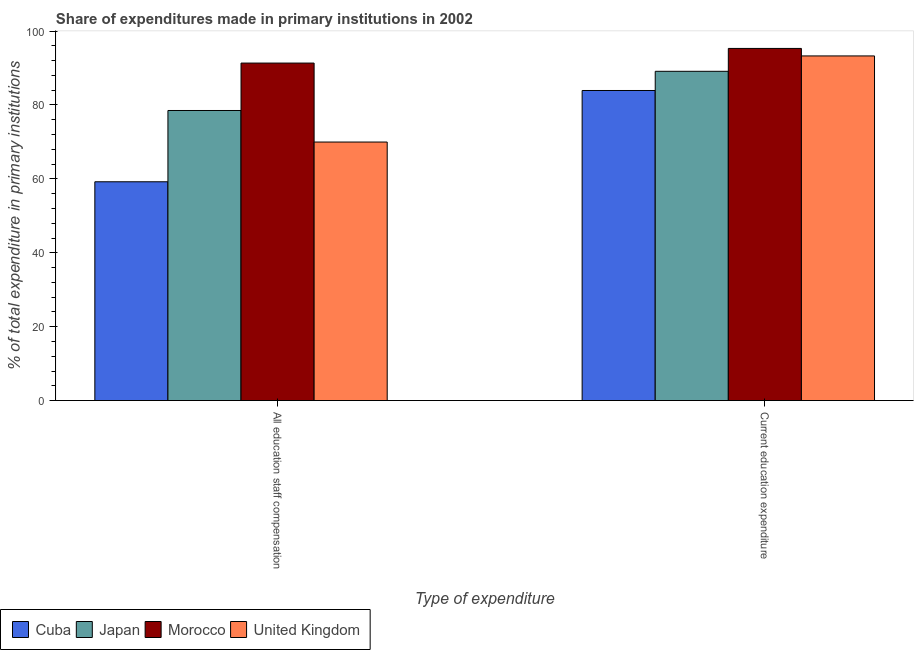How many different coloured bars are there?
Offer a terse response. 4. Are the number of bars on each tick of the X-axis equal?
Provide a short and direct response. Yes. How many bars are there on the 1st tick from the left?
Make the answer very short. 4. How many bars are there on the 1st tick from the right?
Offer a terse response. 4. What is the label of the 2nd group of bars from the left?
Make the answer very short. Current education expenditure. What is the expenditure in staff compensation in Morocco?
Ensure brevity in your answer.  91.35. Across all countries, what is the maximum expenditure in education?
Your answer should be compact. 95.31. Across all countries, what is the minimum expenditure in staff compensation?
Give a very brief answer. 59.22. In which country was the expenditure in education maximum?
Offer a terse response. Morocco. In which country was the expenditure in education minimum?
Make the answer very short. Cuba. What is the total expenditure in staff compensation in the graph?
Keep it short and to the point. 299.05. What is the difference between the expenditure in education in United Kingdom and that in Japan?
Offer a terse response. 4.16. What is the difference between the expenditure in staff compensation in Morocco and the expenditure in education in Japan?
Give a very brief answer. 2.23. What is the average expenditure in education per country?
Your answer should be very brief. 90.41. What is the difference between the expenditure in staff compensation and expenditure in education in United Kingdom?
Your response must be concise. -23.31. In how many countries, is the expenditure in education greater than 12 %?
Give a very brief answer. 4. What is the ratio of the expenditure in education in Cuba to that in Morocco?
Make the answer very short. 0.88. In how many countries, is the expenditure in education greater than the average expenditure in education taken over all countries?
Offer a terse response. 2. What does the 1st bar from the left in All education staff compensation represents?
Make the answer very short. Cuba. What does the 3rd bar from the right in All education staff compensation represents?
Keep it short and to the point. Japan. How many bars are there?
Your answer should be very brief. 8. How many countries are there in the graph?
Offer a very short reply. 4. What is the difference between two consecutive major ticks on the Y-axis?
Keep it short and to the point. 20. Are the values on the major ticks of Y-axis written in scientific E-notation?
Provide a succinct answer. No. How many legend labels are there?
Your answer should be very brief. 4. What is the title of the graph?
Provide a short and direct response. Share of expenditures made in primary institutions in 2002. What is the label or title of the X-axis?
Make the answer very short. Type of expenditure. What is the label or title of the Y-axis?
Make the answer very short. % of total expenditure in primary institutions. What is the % of total expenditure in primary institutions of Cuba in All education staff compensation?
Offer a terse response. 59.22. What is the % of total expenditure in primary institutions of Japan in All education staff compensation?
Offer a very short reply. 78.51. What is the % of total expenditure in primary institutions of Morocco in All education staff compensation?
Give a very brief answer. 91.35. What is the % of total expenditure in primary institutions in United Kingdom in All education staff compensation?
Your answer should be very brief. 69.97. What is the % of total expenditure in primary institutions in Cuba in Current education expenditure?
Your answer should be compact. 83.92. What is the % of total expenditure in primary institutions of Japan in Current education expenditure?
Give a very brief answer. 89.12. What is the % of total expenditure in primary institutions of Morocco in Current education expenditure?
Keep it short and to the point. 95.31. What is the % of total expenditure in primary institutions in United Kingdom in Current education expenditure?
Give a very brief answer. 93.28. Across all Type of expenditure, what is the maximum % of total expenditure in primary institutions in Cuba?
Offer a terse response. 83.92. Across all Type of expenditure, what is the maximum % of total expenditure in primary institutions of Japan?
Keep it short and to the point. 89.12. Across all Type of expenditure, what is the maximum % of total expenditure in primary institutions of Morocco?
Provide a succinct answer. 95.31. Across all Type of expenditure, what is the maximum % of total expenditure in primary institutions in United Kingdom?
Keep it short and to the point. 93.28. Across all Type of expenditure, what is the minimum % of total expenditure in primary institutions in Cuba?
Keep it short and to the point. 59.22. Across all Type of expenditure, what is the minimum % of total expenditure in primary institutions of Japan?
Give a very brief answer. 78.51. Across all Type of expenditure, what is the minimum % of total expenditure in primary institutions of Morocco?
Make the answer very short. 91.35. Across all Type of expenditure, what is the minimum % of total expenditure in primary institutions of United Kingdom?
Offer a terse response. 69.97. What is the total % of total expenditure in primary institutions in Cuba in the graph?
Provide a succinct answer. 143.14. What is the total % of total expenditure in primary institutions of Japan in the graph?
Provide a succinct answer. 167.63. What is the total % of total expenditure in primary institutions of Morocco in the graph?
Provide a short and direct response. 186.66. What is the total % of total expenditure in primary institutions in United Kingdom in the graph?
Your answer should be very brief. 163.25. What is the difference between the % of total expenditure in primary institutions in Cuba in All education staff compensation and that in Current education expenditure?
Your answer should be very brief. -24.71. What is the difference between the % of total expenditure in primary institutions of Japan in All education staff compensation and that in Current education expenditure?
Ensure brevity in your answer.  -10.61. What is the difference between the % of total expenditure in primary institutions in Morocco in All education staff compensation and that in Current education expenditure?
Your answer should be compact. -3.96. What is the difference between the % of total expenditure in primary institutions in United Kingdom in All education staff compensation and that in Current education expenditure?
Your answer should be compact. -23.31. What is the difference between the % of total expenditure in primary institutions of Cuba in All education staff compensation and the % of total expenditure in primary institutions of Japan in Current education expenditure?
Provide a short and direct response. -29.9. What is the difference between the % of total expenditure in primary institutions in Cuba in All education staff compensation and the % of total expenditure in primary institutions in Morocco in Current education expenditure?
Provide a succinct answer. -36.09. What is the difference between the % of total expenditure in primary institutions of Cuba in All education staff compensation and the % of total expenditure in primary institutions of United Kingdom in Current education expenditure?
Your answer should be very brief. -34.06. What is the difference between the % of total expenditure in primary institutions in Japan in All education staff compensation and the % of total expenditure in primary institutions in Morocco in Current education expenditure?
Make the answer very short. -16.8. What is the difference between the % of total expenditure in primary institutions of Japan in All education staff compensation and the % of total expenditure in primary institutions of United Kingdom in Current education expenditure?
Provide a short and direct response. -14.77. What is the difference between the % of total expenditure in primary institutions of Morocco in All education staff compensation and the % of total expenditure in primary institutions of United Kingdom in Current education expenditure?
Ensure brevity in your answer.  -1.93. What is the average % of total expenditure in primary institutions of Cuba per Type of expenditure?
Make the answer very short. 71.57. What is the average % of total expenditure in primary institutions in Japan per Type of expenditure?
Provide a short and direct response. 83.82. What is the average % of total expenditure in primary institutions of Morocco per Type of expenditure?
Make the answer very short. 93.33. What is the average % of total expenditure in primary institutions in United Kingdom per Type of expenditure?
Your answer should be very brief. 81.63. What is the difference between the % of total expenditure in primary institutions of Cuba and % of total expenditure in primary institutions of Japan in All education staff compensation?
Your answer should be compact. -19.3. What is the difference between the % of total expenditure in primary institutions of Cuba and % of total expenditure in primary institutions of Morocco in All education staff compensation?
Your answer should be very brief. -32.13. What is the difference between the % of total expenditure in primary institutions of Cuba and % of total expenditure in primary institutions of United Kingdom in All education staff compensation?
Give a very brief answer. -10.76. What is the difference between the % of total expenditure in primary institutions in Japan and % of total expenditure in primary institutions in Morocco in All education staff compensation?
Your answer should be compact. -12.83. What is the difference between the % of total expenditure in primary institutions in Japan and % of total expenditure in primary institutions in United Kingdom in All education staff compensation?
Offer a very short reply. 8.54. What is the difference between the % of total expenditure in primary institutions in Morocco and % of total expenditure in primary institutions in United Kingdom in All education staff compensation?
Offer a very short reply. 21.37. What is the difference between the % of total expenditure in primary institutions in Cuba and % of total expenditure in primary institutions in Japan in Current education expenditure?
Your response must be concise. -5.19. What is the difference between the % of total expenditure in primary institutions of Cuba and % of total expenditure in primary institutions of Morocco in Current education expenditure?
Your response must be concise. -11.38. What is the difference between the % of total expenditure in primary institutions of Cuba and % of total expenditure in primary institutions of United Kingdom in Current education expenditure?
Offer a very short reply. -9.36. What is the difference between the % of total expenditure in primary institutions in Japan and % of total expenditure in primary institutions in Morocco in Current education expenditure?
Offer a terse response. -6.19. What is the difference between the % of total expenditure in primary institutions in Japan and % of total expenditure in primary institutions in United Kingdom in Current education expenditure?
Make the answer very short. -4.16. What is the difference between the % of total expenditure in primary institutions in Morocco and % of total expenditure in primary institutions in United Kingdom in Current education expenditure?
Your answer should be very brief. 2.03. What is the ratio of the % of total expenditure in primary institutions in Cuba in All education staff compensation to that in Current education expenditure?
Make the answer very short. 0.71. What is the ratio of the % of total expenditure in primary institutions of Japan in All education staff compensation to that in Current education expenditure?
Your answer should be compact. 0.88. What is the ratio of the % of total expenditure in primary institutions in Morocco in All education staff compensation to that in Current education expenditure?
Offer a terse response. 0.96. What is the ratio of the % of total expenditure in primary institutions in United Kingdom in All education staff compensation to that in Current education expenditure?
Your answer should be compact. 0.75. What is the difference between the highest and the second highest % of total expenditure in primary institutions in Cuba?
Offer a very short reply. 24.71. What is the difference between the highest and the second highest % of total expenditure in primary institutions of Japan?
Your response must be concise. 10.61. What is the difference between the highest and the second highest % of total expenditure in primary institutions of Morocco?
Your response must be concise. 3.96. What is the difference between the highest and the second highest % of total expenditure in primary institutions of United Kingdom?
Make the answer very short. 23.31. What is the difference between the highest and the lowest % of total expenditure in primary institutions of Cuba?
Offer a very short reply. 24.71. What is the difference between the highest and the lowest % of total expenditure in primary institutions of Japan?
Your response must be concise. 10.61. What is the difference between the highest and the lowest % of total expenditure in primary institutions in Morocco?
Your answer should be very brief. 3.96. What is the difference between the highest and the lowest % of total expenditure in primary institutions in United Kingdom?
Your answer should be compact. 23.31. 